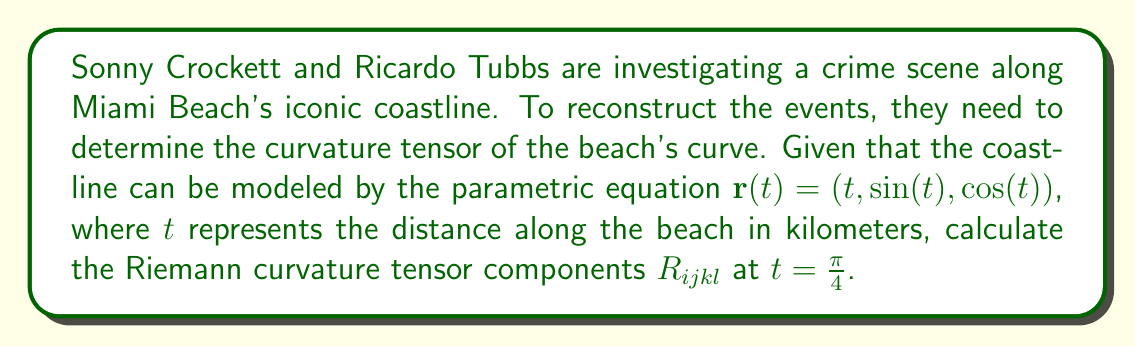Provide a solution to this math problem. To determine the Riemann curvature tensor, we'll follow these steps:

1) First, we need to calculate the metric tensor $g_{ij}$:
   $$\mathbf{r}'(t) = (1, \cos(t), -\sin(t))$$
   $$g_{11} = 1^2 + \cos^2(t) + \sin^2(t) = 2$$
   $$g_{12} = g_{21} = 0$$
   $$g_{22} = 1$$

2) The inverse metric tensor $g^{ij}$ is:
   $$g^{11} = \frac{1}{2}, g^{12} = g^{21} = 0, g^{22} = 1$$

3) Calculate the Christoffel symbols:
   $$\Gamma^i_{jk} = \frac{1}{2}g^{im}(\partial_j g_{km} + \partial_k g_{jm} - \partial_m g_{jk})$$
   The only non-zero Christoffel symbols are:
   $$\Gamma^1_{22} = -\frac{1}{2}, \Gamma^2_{12} = \Gamma^2_{21} = \frac{1}{2}\cot(t)$$

4) The Riemann curvature tensor is given by:
   $$R^i_{jkl} = \partial_k \Gamma^i_{jl} - \partial_l \Gamma^i_{jk} + \Gamma^m_{jl}\Gamma^i_{km} - \Gamma^m_{jk}\Gamma^i_{lm}$$

5) Calculate the non-zero components at $t = \frac{\pi}{4}$:
   $$R^1_{212} = -R^1_{221} = \frac{1}{4}$$
   $$R^2_{121} = -R^2_{112} = \frac{1}{2}$$

6) Lower the first index to get $R_{ijkl}$:
   $$R_{1212} = -R_{1221} = R_{2121} = -R_{2112} = \frac{1}{2}$$

All other components are zero due to the symmetries of the Riemann tensor.
Answer: $R_{1212} = -R_{1221} = R_{2121} = -R_{2112} = \frac{1}{2}$, all other $R_{ijkl} = 0$ 